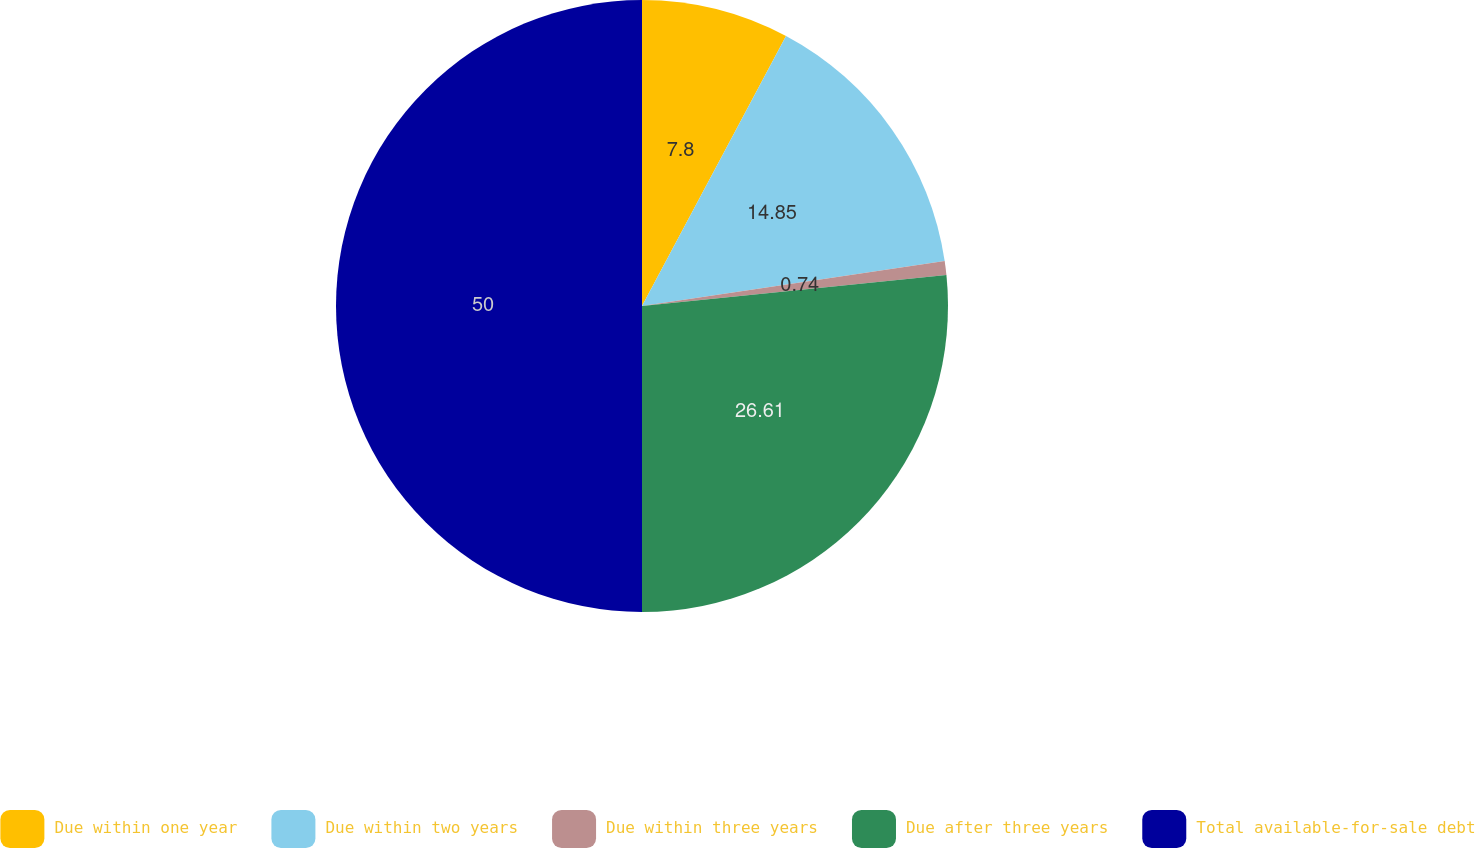Convert chart to OTSL. <chart><loc_0><loc_0><loc_500><loc_500><pie_chart><fcel>Due within one year<fcel>Due within two years<fcel>Due within three years<fcel>Due after three years<fcel>Total available-for-sale debt<nl><fcel>7.8%<fcel>14.85%<fcel>0.74%<fcel>26.61%<fcel>50.0%<nl></chart> 